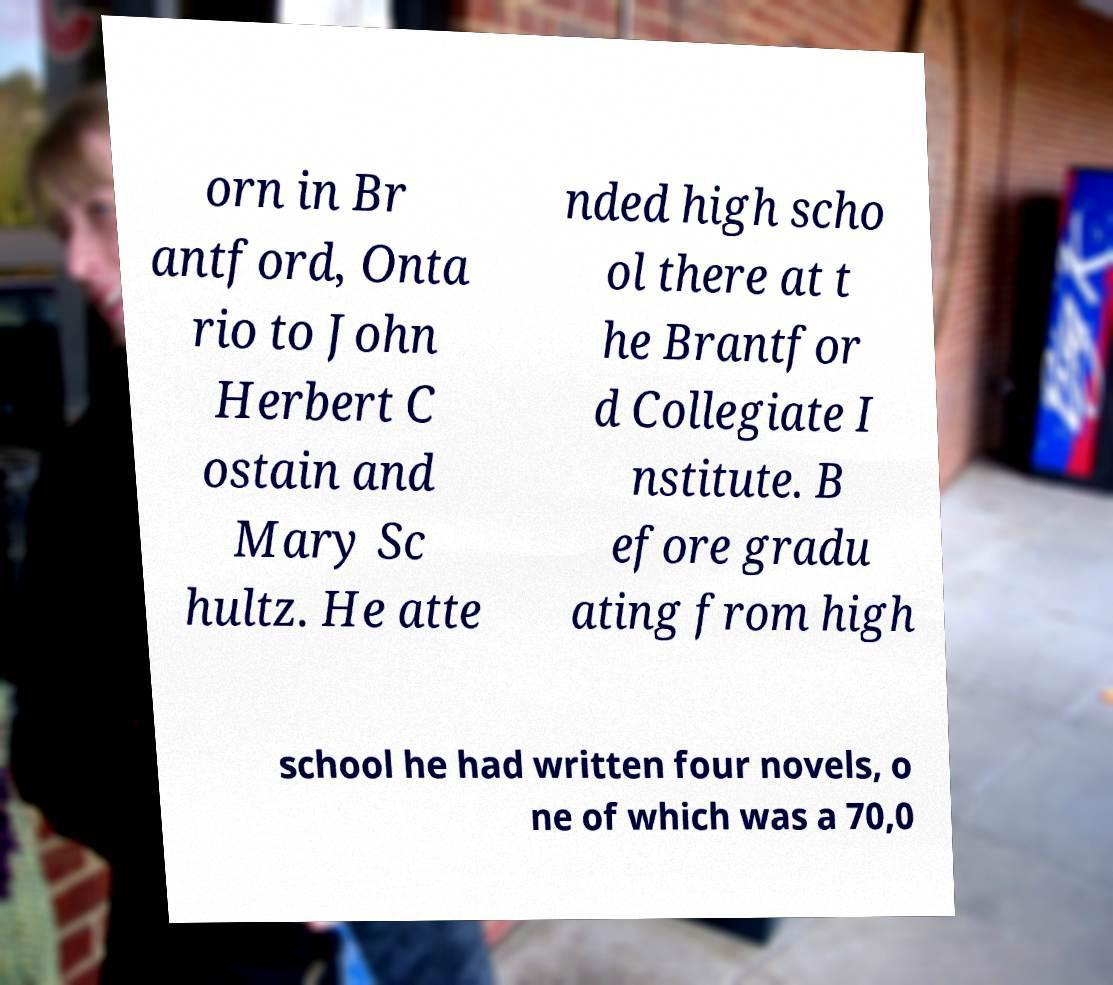For documentation purposes, I need the text within this image transcribed. Could you provide that? orn in Br antford, Onta rio to John Herbert C ostain and Mary Sc hultz. He atte nded high scho ol there at t he Brantfor d Collegiate I nstitute. B efore gradu ating from high school he had written four novels, o ne of which was a 70,0 